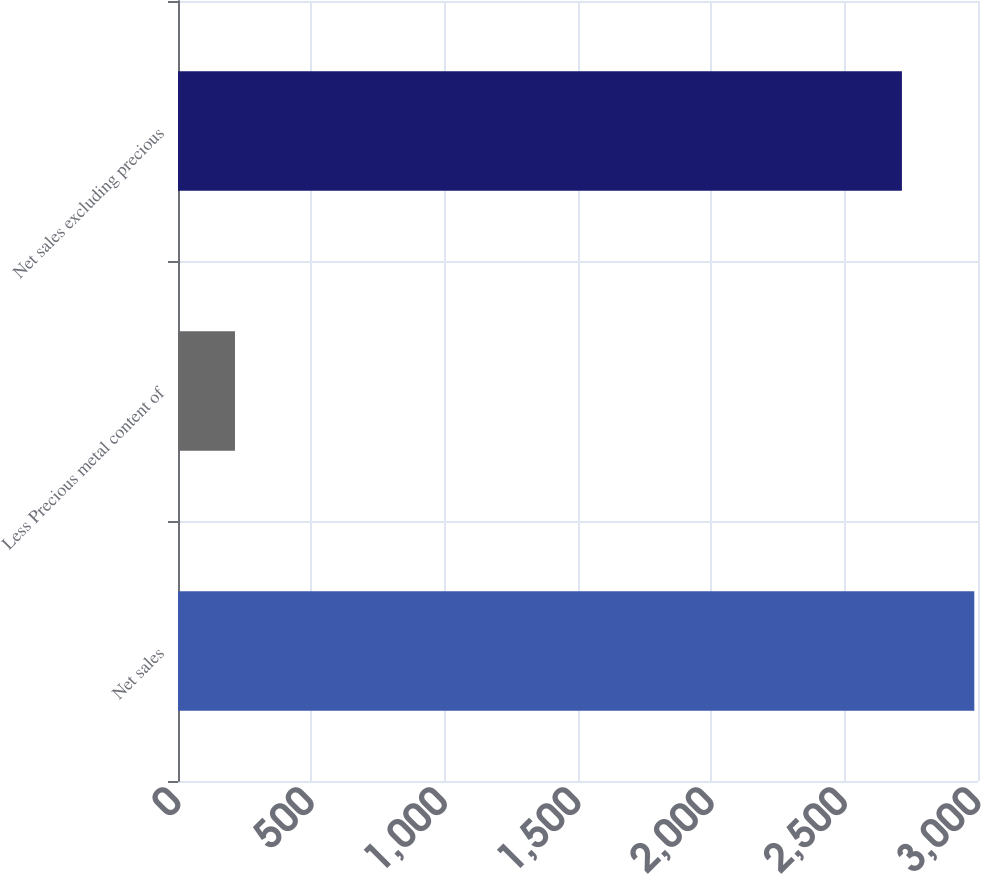Convert chart to OTSL. <chart><loc_0><loc_0><loc_500><loc_500><bar_chart><fcel>Net sales<fcel>Less Precious metal content of<fcel>Net sales excluding precious<nl><fcel>2986.17<fcel>213.7<fcel>2714.7<nl></chart> 